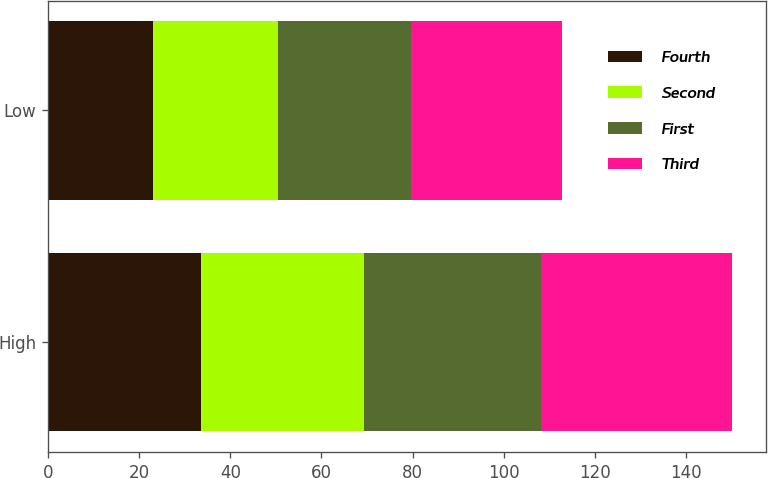Convert chart. <chart><loc_0><loc_0><loc_500><loc_500><stacked_bar_chart><ecel><fcel>High<fcel>Low<nl><fcel>Fourth<fcel>33.5<fcel>23.06<nl><fcel>Second<fcel>35.92<fcel>27.41<nl><fcel>First<fcel>38.82<fcel>29.14<nl><fcel>Third<fcel>41.87<fcel>33.22<nl></chart> 